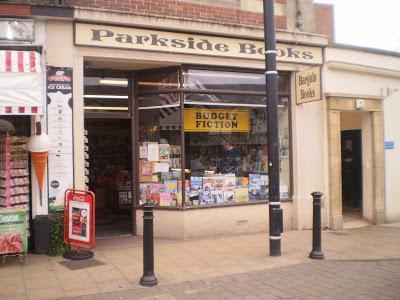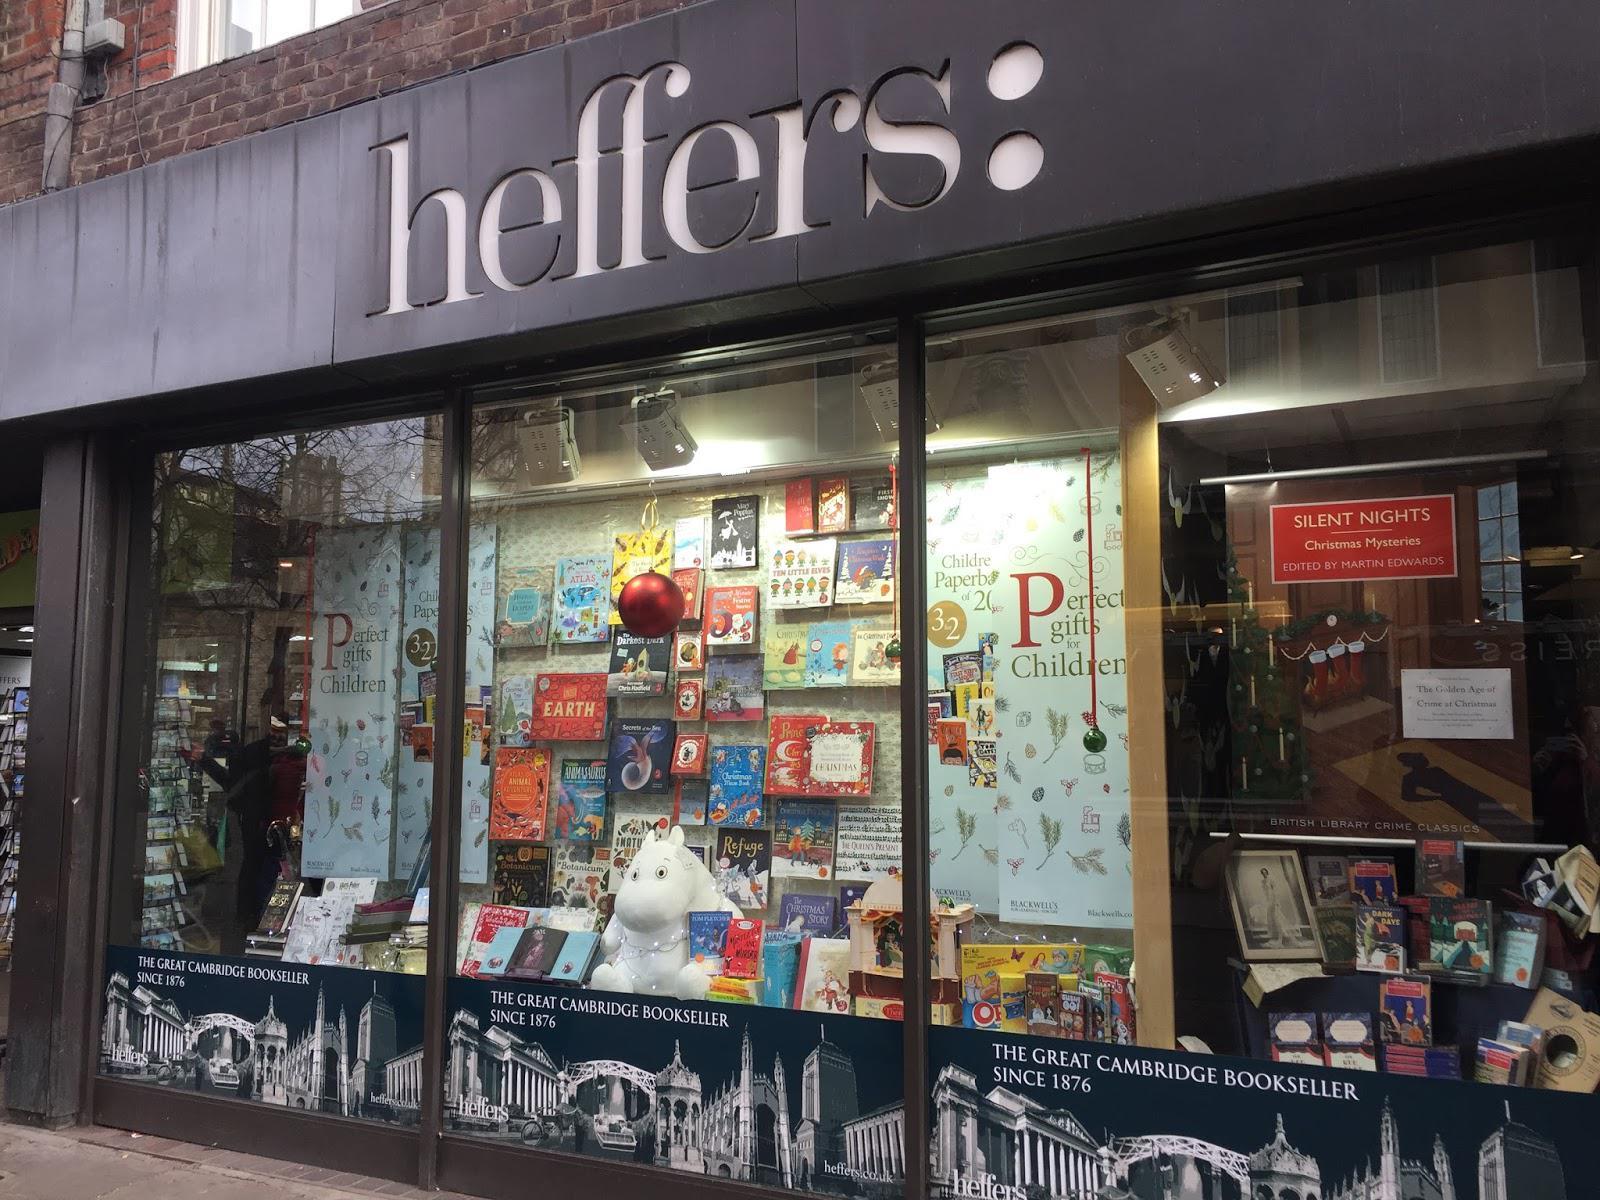The first image is the image on the left, the second image is the image on the right. Analyze the images presented: Is the assertion "At least one person is walking outside of one of the stores." valid? Answer yes or no. No. The first image is the image on the left, the second image is the image on the right. Assess this claim about the two images: "There is a storefront in each image.". Correct or not? Answer yes or no. Yes. 